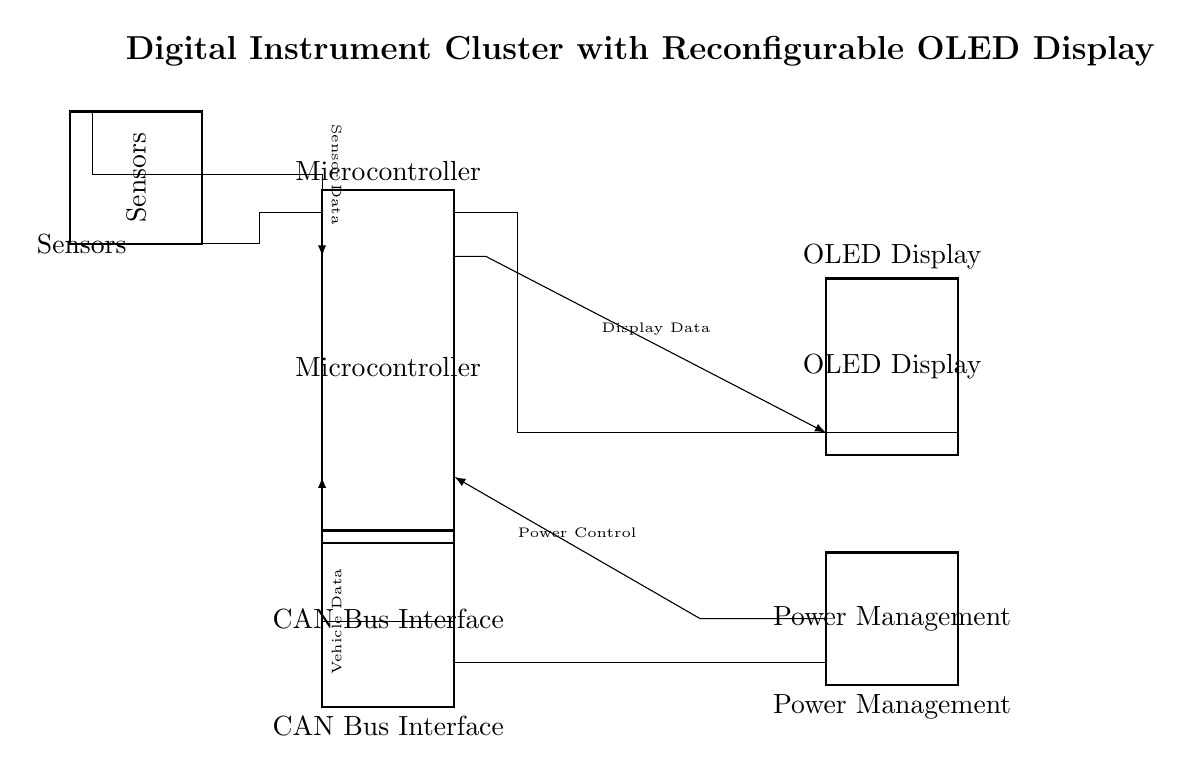What is the main component of the circuit? The main component is the microcontroller, which typically handles processing tasks and connections to other components.
Answer: microcontroller How many pins does the OLED display have? The OLED display has 8 pins as specified in the diagram, which indicates its connectivity options.
Answer: 8 What signals are sent from the sensors to the microcontroller? Sensor data signals are sent from the sensors to the microcontroller via an arrow indicating the direction of data flow.
Answer: Sensor Data What type of interface is included in the circuit? The CAN bus interface is included, which is commonly used in automotive applications for vehicle data communication.
Answer: CAN Bus Interface Which component manages power in the circuit? The power management component is responsible for regulating and distributing power within the circuit, as indicated in the diagram.
Answer: Power Management What is the connection from the microcontroller to the OLED display labeled as? The connection is labeled as display data, which means this line transfers processed information from the microcontroller to be displayed on the OLED.
Answer: Display Data How does the CAN bus interface interact with the microcontroller? The CAN bus interface sends vehicle data to the microcontroller, allowing it to process and display relevant information about the vehicle's operation.
Answer: Vehicle Data 